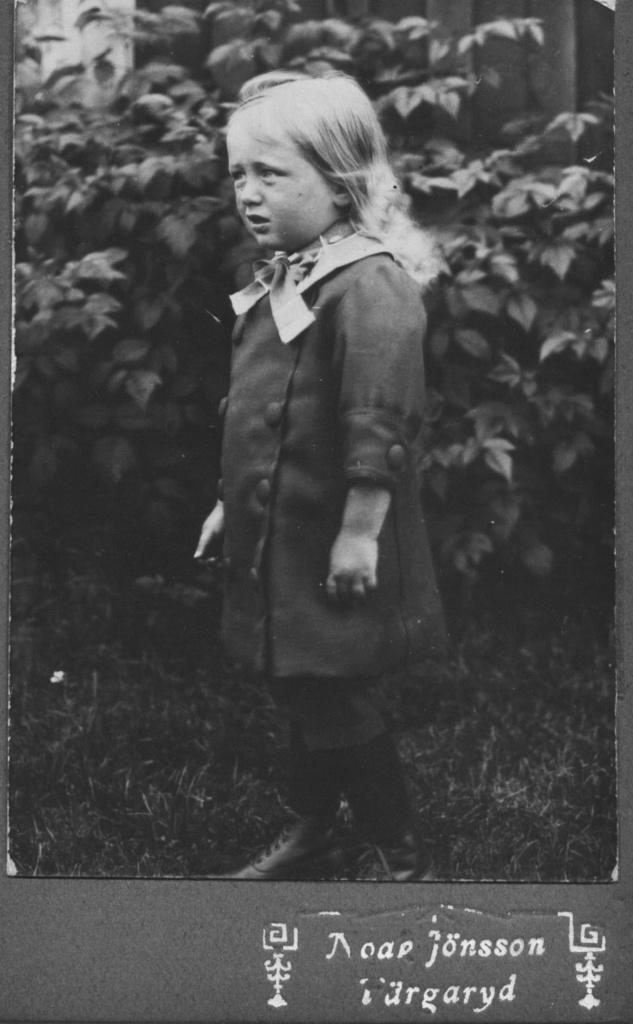What is the color scheme of the image? The image is black and white. What can be seen in the foreground of the image? There is a girl standing in the image. What is the girl wearing? The girl is wearing a dress. What type of vegetation is visible in the background of the image? There are plants behind the girl. How many dimes are scattered on the ground in the image? There are no dimes present in the image. What type of brush is being used by the girl in the image? There is no brush visible in the image; the girl is simply standing. 